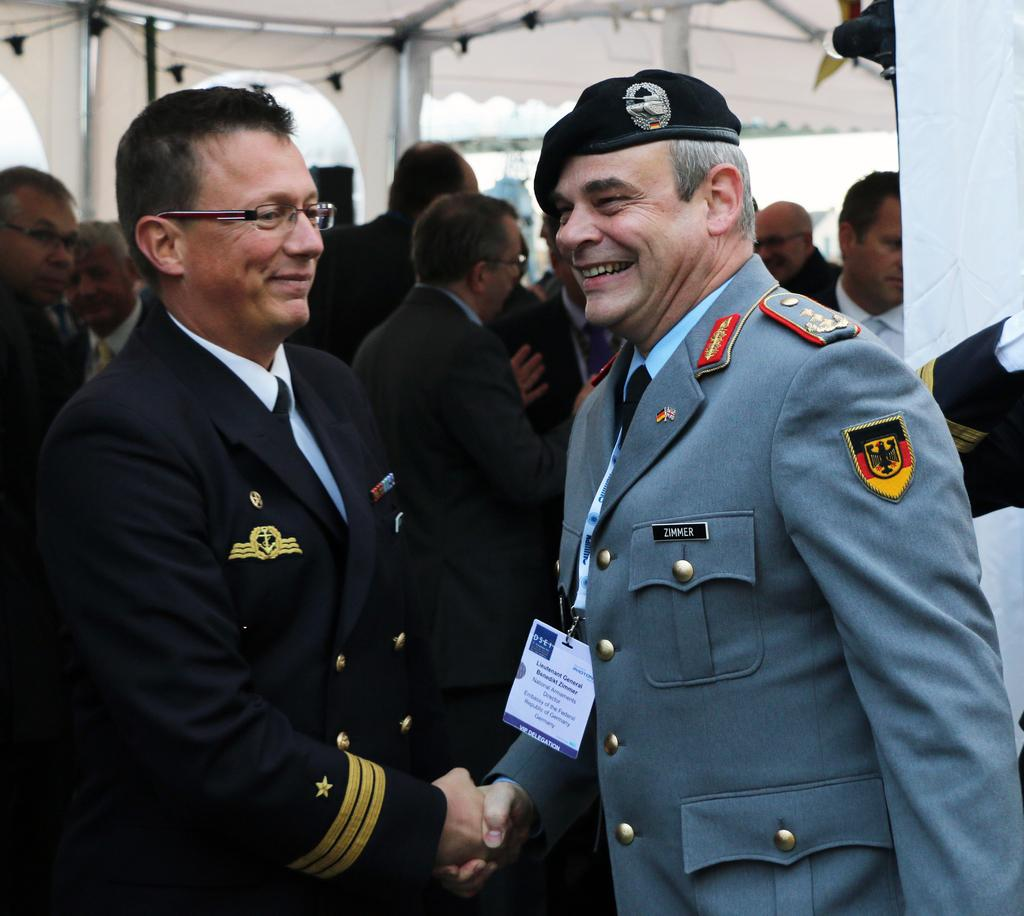How many people are in the image? There are two men in the image. What are the men doing in the image? The men are standing and shaking hands. What is the facial expression of the men in the image? The men are smiling in the image. What can be seen in the background of the image? There is a group of people and a tent in the background of the image. What type of curtain is hanging in the background of the image? There is no curtain present in the image. What flavor of mint is being shared between the men in the image? There is no mint present in the image; the men are shaking hands. 